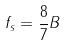<formula> <loc_0><loc_0><loc_500><loc_500>f _ { s } = \frac { 8 } { 7 } B</formula> 